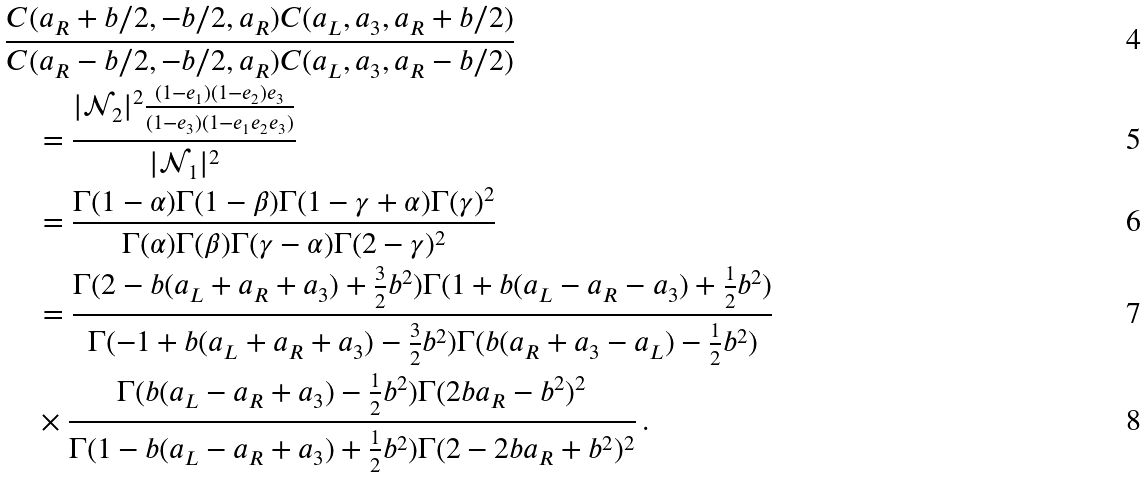<formula> <loc_0><loc_0><loc_500><loc_500>& \frac { C ( a _ { R } + b / 2 , - b / 2 , a _ { R } ) C ( a _ { L } , a _ { 3 } , a _ { R } + b / 2 ) } { C ( a _ { R } - b / 2 , - b / 2 , a _ { R } ) C ( a _ { L } , a _ { 3 } , a _ { R } - b / 2 ) } \\ & \quad = \frac { | \mathcal { N } _ { 2 } | ^ { 2 } \frac { ( 1 - e _ { 1 } ) ( 1 - e _ { 2 } ) e _ { 3 } } { ( 1 - e _ { 3 } ) ( 1 - e _ { 1 } e _ { 2 } e _ { 3 } ) } } { | \mathcal { N } _ { 1 } | ^ { 2 } } \\ & \quad = \frac { \Gamma ( 1 - \alpha ) \Gamma ( 1 - \beta ) \Gamma ( 1 - \gamma + \alpha ) \Gamma ( \gamma ) ^ { 2 } } { \Gamma ( \alpha ) \Gamma ( \beta ) \Gamma ( \gamma - \alpha ) \Gamma ( 2 - \gamma ) ^ { 2 } } \\ & \quad = \frac { \Gamma ( 2 - b ( a _ { L } + a _ { R } + a _ { 3 } ) + \frac { 3 } { 2 } b ^ { 2 } ) \Gamma ( 1 + b ( a _ { L } - a _ { R } - a _ { 3 } ) + \frac { 1 } { 2 } b ^ { 2 } ) } { \Gamma ( - 1 + b ( a _ { L } + a _ { R } + a _ { 3 } ) - \frac { 3 } { 2 } b ^ { 2 } ) \Gamma ( b ( a _ { R } + a _ { 3 } - a _ { L } ) - \frac { 1 } { 2 } b ^ { 2 } ) } \\ & \quad \times \frac { \Gamma ( b ( a _ { L } - a _ { R } + a _ { 3 } ) - \frac { 1 } { 2 } b ^ { 2 } ) \Gamma ( 2 b a _ { R } - b ^ { 2 } ) ^ { 2 } } { \Gamma ( 1 - b ( a _ { L } - a _ { R } + a _ { 3 } ) + \frac { 1 } { 2 } b ^ { 2 } ) \Gamma ( 2 - 2 b a _ { R } + b ^ { 2 } ) ^ { 2 } } \, .</formula> 